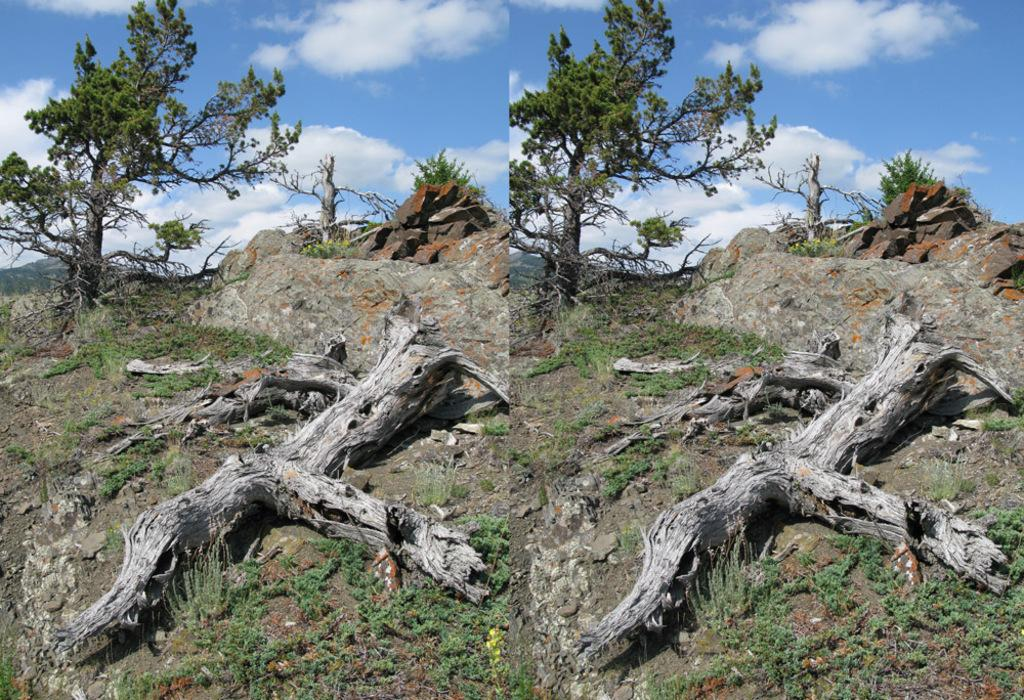What is the main subject of the image? The main subject of the image is a collage of pictures. What types of natural elements are included in the collage? The collage includes pictures of trees, grass, the sky, and clouds. Are there any boys shown playing on a swing in the image? There is no reference to boys or a swing in the image; it features a collage of pictures of natural elements. 